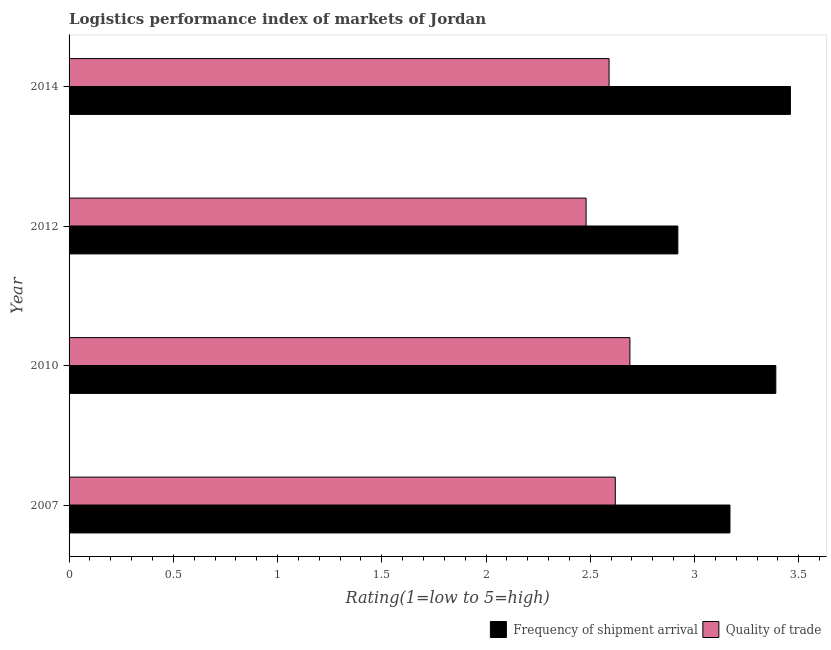How many different coloured bars are there?
Provide a short and direct response. 2. How many groups of bars are there?
Offer a very short reply. 4. Are the number of bars per tick equal to the number of legend labels?
Offer a terse response. Yes. How many bars are there on the 2nd tick from the top?
Make the answer very short. 2. How many bars are there on the 2nd tick from the bottom?
Your answer should be very brief. 2. In how many cases, is the number of bars for a given year not equal to the number of legend labels?
Ensure brevity in your answer.  0. What is the lpi of frequency of shipment arrival in 2014?
Ensure brevity in your answer.  3.46. Across all years, what is the maximum lpi of frequency of shipment arrival?
Ensure brevity in your answer.  3.46. Across all years, what is the minimum lpi quality of trade?
Give a very brief answer. 2.48. What is the total lpi quality of trade in the graph?
Ensure brevity in your answer.  10.38. What is the difference between the lpi of frequency of shipment arrival in 2007 and that in 2010?
Offer a terse response. -0.22. What is the difference between the lpi quality of trade in 2010 and the lpi of frequency of shipment arrival in 2007?
Ensure brevity in your answer.  -0.48. What is the average lpi of frequency of shipment arrival per year?
Provide a succinct answer. 3.23. In how many years, is the lpi quality of trade greater than 2.7 ?
Offer a terse response. 0. What is the ratio of the lpi quality of trade in 2007 to that in 2014?
Offer a very short reply. 1.01. Is the lpi of frequency of shipment arrival in 2007 less than that in 2014?
Your response must be concise. Yes. What is the difference between the highest and the second highest lpi of frequency of shipment arrival?
Your answer should be compact. 0.07. What is the difference between the highest and the lowest lpi quality of trade?
Provide a short and direct response. 0.21. What does the 1st bar from the top in 2014 represents?
Provide a short and direct response. Quality of trade. What does the 1st bar from the bottom in 2007 represents?
Your answer should be compact. Frequency of shipment arrival. How many years are there in the graph?
Your answer should be very brief. 4. Does the graph contain any zero values?
Offer a very short reply. No. Does the graph contain grids?
Your answer should be very brief. No. Where does the legend appear in the graph?
Ensure brevity in your answer.  Bottom right. How are the legend labels stacked?
Offer a terse response. Horizontal. What is the title of the graph?
Offer a very short reply. Logistics performance index of markets of Jordan. What is the label or title of the X-axis?
Give a very brief answer. Rating(1=low to 5=high). What is the Rating(1=low to 5=high) of Frequency of shipment arrival in 2007?
Offer a terse response. 3.17. What is the Rating(1=low to 5=high) of Quality of trade in 2007?
Provide a short and direct response. 2.62. What is the Rating(1=low to 5=high) in Frequency of shipment arrival in 2010?
Your answer should be compact. 3.39. What is the Rating(1=low to 5=high) in Quality of trade in 2010?
Keep it short and to the point. 2.69. What is the Rating(1=low to 5=high) of Frequency of shipment arrival in 2012?
Make the answer very short. 2.92. What is the Rating(1=low to 5=high) in Quality of trade in 2012?
Keep it short and to the point. 2.48. What is the Rating(1=low to 5=high) in Frequency of shipment arrival in 2014?
Your answer should be very brief. 3.46. What is the Rating(1=low to 5=high) in Quality of trade in 2014?
Ensure brevity in your answer.  2.59. Across all years, what is the maximum Rating(1=low to 5=high) of Frequency of shipment arrival?
Ensure brevity in your answer.  3.46. Across all years, what is the maximum Rating(1=low to 5=high) of Quality of trade?
Your answer should be very brief. 2.69. Across all years, what is the minimum Rating(1=low to 5=high) of Frequency of shipment arrival?
Your response must be concise. 2.92. Across all years, what is the minimum Rating(1=low to 5=high) in Quality of trade?
Make the answer very short. 2.48. What is the total Rating(1=low to 5=high) in Frequency of shipment arrival in the graph?
Offer a very short reply. 12.94. What is the total Rating(1=low to 5=high) of Quality of trade in the graph?
Your answer should be compact. 10.38. What is the difference between the Rating(1=low to 5=high) in Frequency of shipment arrival in 2007 and that in 2010?
Provide a succinct answer. -0.22. What is the difference between the Rating(1=low to 5=high) in Quality of trade in 2007 and that in 2010?
Your answer should be compact. -0.07. What is the difference between the Rating(1=low to 5=high) in Quality of trade in 2007 and that in 2012?
Offer a terse response. 0.14. What is the difference between the Rating(1=low to 5=high) in Frequency of shipment arrival in 2007 and that in 2014?
Provide a short and direct response. -0.29. What is the difference between the Rating(1=low to 5=high) in Quality of trade in 2007 and that in 2014?
Your answer should be compact. 0.03. What is the difference between the Rating(1=low to 5=high) in Frequency of shipment arrival in 2010 and that in 2012?
Your response must be concise. 0.47. What is the difference between the Rating(1=low to 5=high) of Quality of trade in 2010 and that in 2012?
Provide a succinct answer. 0.21. What is the difference between the Rating(1=low to 5=high) of Frequency of shipment arrival in 2010 and that in 2014?
Provide a succinct answer. -0.07. What is the difference between the Rating(1=low to 5=high) in Quality of trade in 2010 and that in 2014?
Your response must be concise. 0.1. What is the difference between the Rating(1=low to 5=high) of Frequency of shipment arrival in 2012 and that in 2014?
Keep it short and to the point. -0.54. What is the difference between the Rating(1=low to 5=high) in Quality of trade in 2012 and that in 2014?
Your answer should be compact. -0.11. What is the difference between the Rating(1=low to 5=high) of Frequency of shipment arrival in 2007 and the Rating(1=low to 5=high) of Quality of trade in 2010?
Offer a terse response. 0.48. What is the difference between the Rating(1=low to 5=high) in Frequency of shipment arrival in 2007 and the Rating(1=low to 5=high) in Quality of trade in 2012?
Ensure brevity in your answer.  0.69. What is the difference between the Rating(1=low to 5=high) in Frequency of shipment arrival in 2007 and the Rating(1=low to 5=high) in Quality of trade in 2014?
Provide a succinct answer. 0.58. What is the difference between the Rating(1=low to 5=high) in Frequency of shipment arrival in 2010 and the Rating(1=low to 5=high) in Quality of trade in 2012?
Provide a succinct answer. 0.91. What is the difference between the Rating(1=low to 5=high) in Frequency of shipment arrival in 2010 and the Rating(1=low to 5=high) in Quality of trade in 2014?
Your answer should be very brief. 0.8. What is the difference between the Rating(1=low to 5=high) in Frequency of shipment arrival in 2012 and the Rating(1=low to 5=high) in Quality of trade in 2014?
Keep it short and to the point. 0.33. What is the average Rating(1=low to 5=high) in Frequency of shipment arrival per year?
Keep it short and to the point. 3.23. What is the average Rating(1=low to 5=high) of Quality of trade per year?
Offer a very short reply. 2.6. In the year 2007, what is the difference between the Rating(1=low to 5=high) in Frequency of shipment arrival and Rating(1=low to 5=high) in Quality of trade?
Give a very brief answer. 0.55. In the year 2012, what is the difference between the Rating(1=low to 5=high) of Frequency of shipment arrival and Rating(1=low to 5=high) of Quality of trade?
Ensure brevity in your answer.  0.44. In the year 2014, what is the difference between the Rating(1=low to 5=high) in Frequency of shipment arrival and Rating(1=low to 5=high) in Quality of trade?
Keep it short and to the point. 0.87. What is the ratio of the Rating(1=low to 5=high) of Frequency of shipment arrival in 2007 to that in 2010?
Keep it short and to the point. 0.94. What is the ratio of the Rating(1=low to 5=high) in Frequency of shipment arrival in 2007 to that in 2012?
Offer a terse response. 1.09. What is the ratio of the Rating(1=low to 5=high) in Quality of trade in 2007 to that in 2012?
Make the answer very short. 1.06. What is the ratio of the Rating(1=low to 5=high) in Frequency of shipment arrival in 2007 to that in 2014?
Make the answer very short. 0.92. What is the ratio of the Rating(1=low to 5=high) of Quality of trade in 2007 to that in 2014?
Provide a short and direct response. 1.01. What is the ratio of the Rating(1=low to 5=high) in Frequency of shipment arrival in 2010 to that in 2012?
Keep it short and to the point. 1.16. What is the ratio of the Rating(1=low to 5=high) of Quality of trade in 2010 to that in 2012?
Keep it short and to the point. 1.08. What is the ratio of the Rating(1=low to 5=high) in Frequency of shipment arrival in 2010 to that in 2014?
Provide a short and direct response. 0.98. What is the ratio of the Rating(1=low to 5=high) of Quality of trade in 2010 to that in 2014?
Provide a short and direct response. 1.04. What is the ratio of the Rating(1=low to 5=high) of Frequency of shipment arrival in 2012 to that in 2014?
Provide a succinct answer. 0.84. What is the ratio of the Rating(1=low to 5=high) in Quality of trade in 2012 to that in 2014?
Make the answer very short. 0.96. What is the difference between the highest and the second highest Rating(1=low to 5=high) of Frequency of shipment arrival?
Provide a succinct answer. 0.07. What is the difference between the highest and the second highest Rating(1=low to 5=high) in Quality of trade?
Keep it short and to the point. 0.07. What is the difference between the highest and the lowest Rating(1=low to 5=high) of Frequency of shipment arrival?
Your answer should be compact. 0.54. What is the difference between the highest and the lowest Rating(1=low to 5=high) in Quality of trade?
Your answer should be very brief. 0.21. 